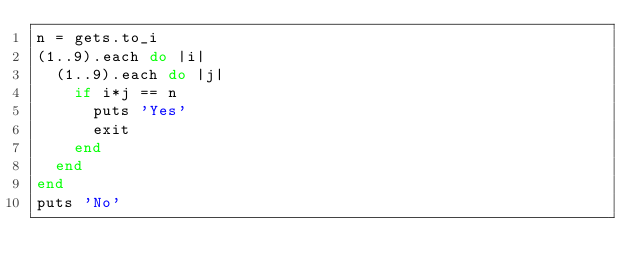<code> <loc_0><loc_0><loc_500><loc_500><_Ruby_>n = gets.to_i
(1..9).each do |i|
  (1..9).each do |j|
    if i*j == n
      puts 'Yes'
      exit
    end
  end
end
puts 'No'
     </code> 